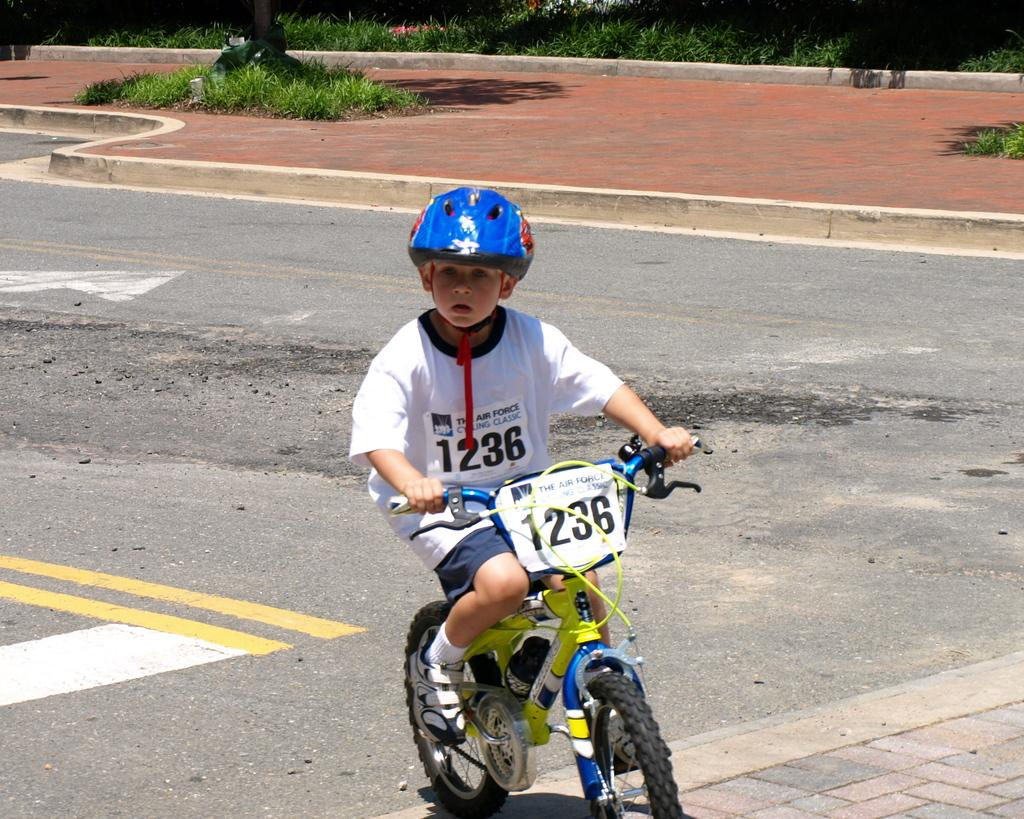What is the main subject of the image? The main subject of the image is a kid. What is the kid doing in the image? The kid is riding a bicycle in the image. Is the kid wearing any protective gear while riding the bicycle? Yes, the kid is wearing a helmet in the image. What type of terrain can be seen in the image? There is grass visible in the image. What decision is the kid making in the image? The image does not depict the kid making any decisions; it shows the kid riding a bicycle. Can you see any cemetery in the image? No, there is no cemetery present in the image. 